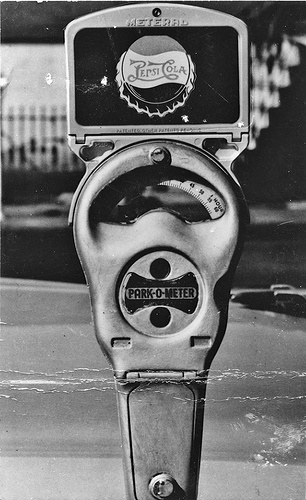Describe the objects in this image and their specific colors. I can see a parking meter in white, black, darkgray, gray, and lightgray tones in this image. 